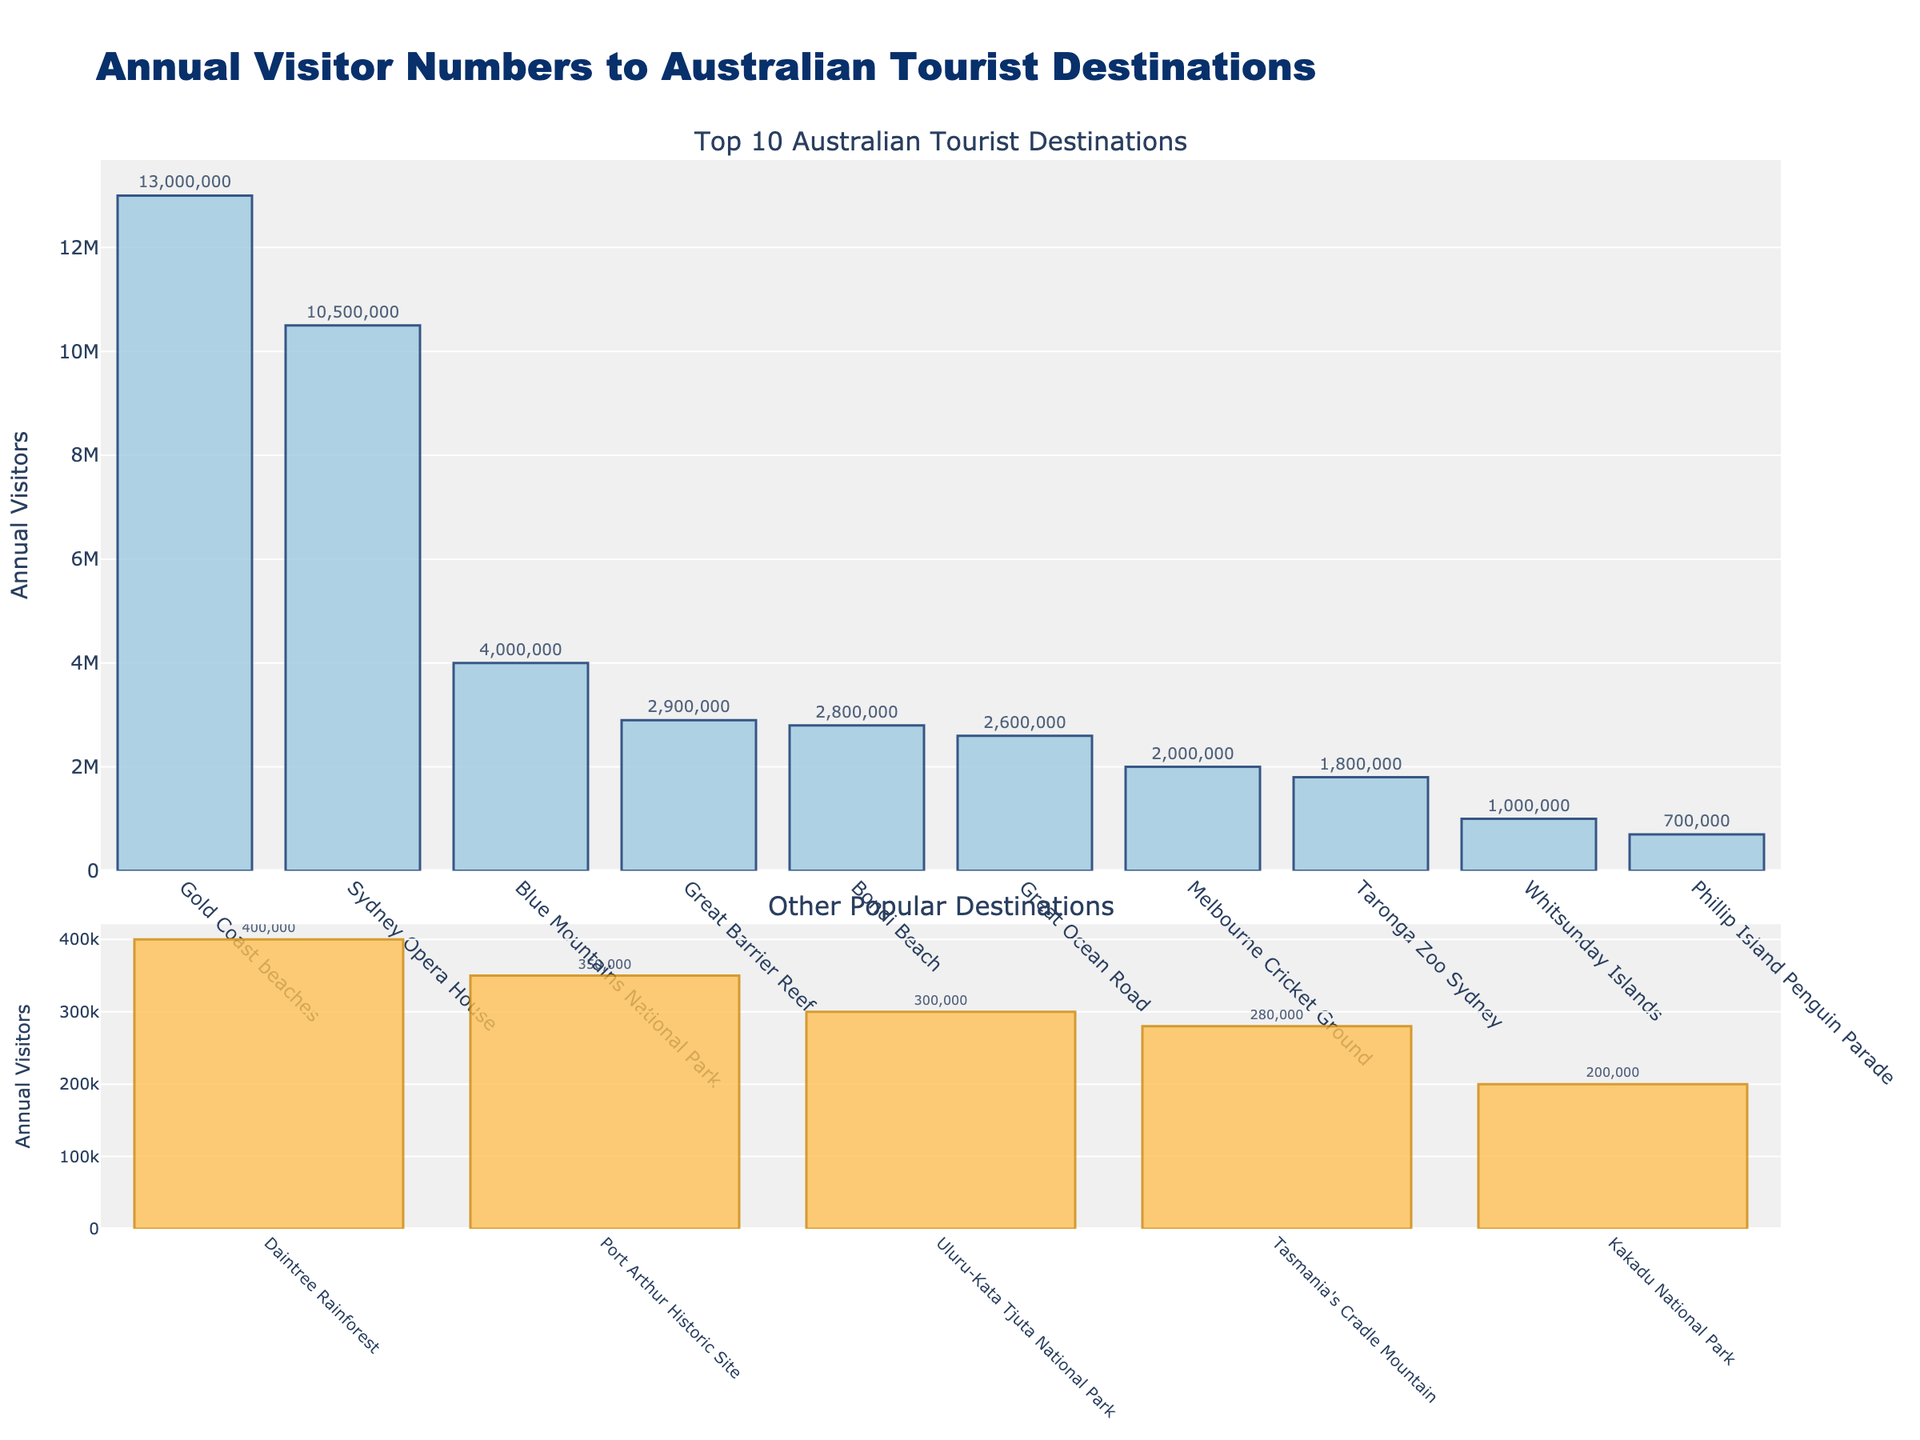what is the most visited tourist destination in Australia? The main bar chart in the figure shows the annual visitor numbers for each destination. The tallest bar represents the most visited destination. In this case, it is the "Gold Coast beaches" with 13,000,000 annual visitors.
Answer: Gold Coast beaches How many people visit the Sydney Opera House compared to the Melbourne Cricket Ground annually? To compare the annual visitors to both destinations, look at their respective bars in the main chart. The Sydney Opera House has 10,500,000 visitors, whereas the Melbourne Cricket Ground has 2,000,000 visitors.
Answer: Sydney Opera House has 8,500,000 more visitors What is the combined annual visitor count for Bondi Beach and the Great Ocean Road? To find the combined annual visitor count, add the visitor numbers for Bondi Beach (2,800,000) and the Great Ocean Road (2,600,000). The sum is 5,400,000.
Answer: 5,400,000 Which tourist destination has the least number of annual visitors and how many? In the secondary bar chart at the bottom, the shortest bar has the least number of annual visitors. "Kakadu National Park" has 200,000 visitors annually.
Answer: Kakadu National Park, 200,000 What is the average annual visitors of the top 3 most visited destinations? First, identify the top 3 most visited destinations: Gold Coast beaches (13,000,000), Sydney Opera House (10,500,000), and Blue Mountains National Park (4,000,000). Add their visitor counts and divide by 3: (13,000,000 + 10,500,000 + 4,000,000) / 3 = 27,500,000 / 3 = 9,166,667.
Answer: 9,166,667 Is there a significant difference in visitor numbers between the Gold Coast beaches and the Great Barrier Reef? Compare the height of the bars for the Gold Coast beaches (13,000,000 visitors) and the Great Barrier Reef (2,900,000 visitors). The difference is 10,100,000 visitors, which is significant.
Answer: Yes, 10,100,000 Which tourist destination appears fourth in the main chart, and how many annual visitors does it have? The fourth bar in the main chart represents the "Blue Mountains National Park" with 4,000,000 annual visitors.
Answer: Blue Mountains National Park, 4,000,000 What's the total number of annual visitors for the destinations in the secondary chart? Add the visitor numbers for each destination in the secondary chart: Taronga Zoo Sydney (1,800,000), Port Arthur Historic Site (350,000), Phillip Island Penguin Parade (700,000), Whitsunday Islands (1,000,000), Tasmania's Cradle Mountain (280,000). The total is 1,800,000 + 350,000 + 700,000 + 1,000,000 + 280,000 = 4,130,000.
Answer: 4,130,000 How does the annual visitor count of Phillip Island Penguin Parade compare to Daintree Rainforest? Look at their respective bars in the secondary chart. Phillip Island Penguin Parade has 700,000 visitors, and Daintree Rainforest has 400,000 visitors.
Answer: Phillip Island Penguin Parade has 300,000 more Which color is used for the bars representing the top 10 most visited destinations? Observe the color of the bars in the main chart. The bars for the top 10 destinations are shaded in a blueish color.
Answer: Blue 